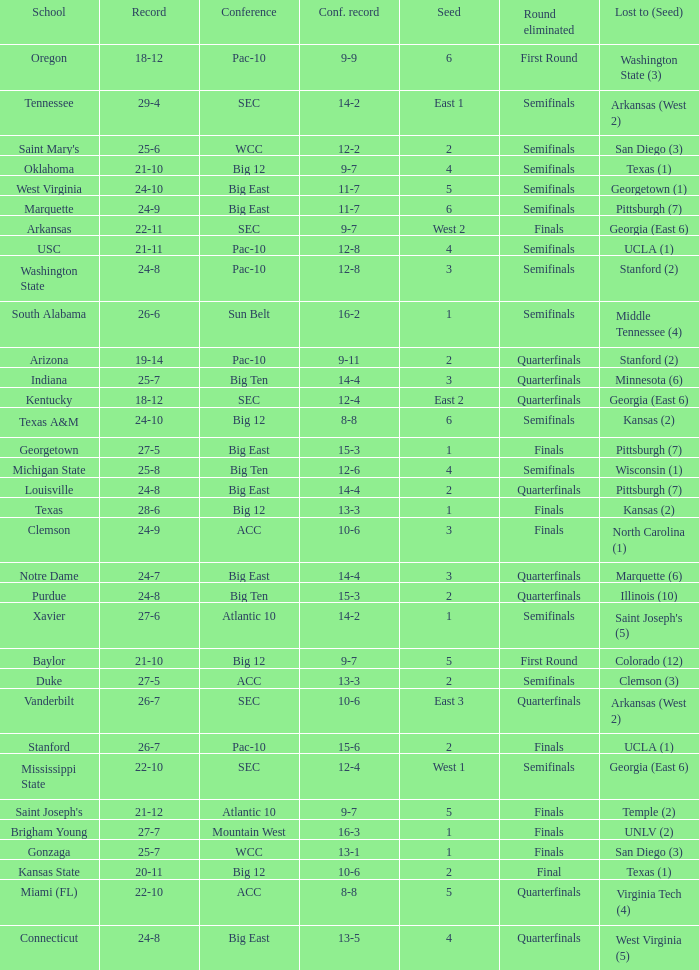Name the conference record where seed is 3 and record is 24-9 10-6. 